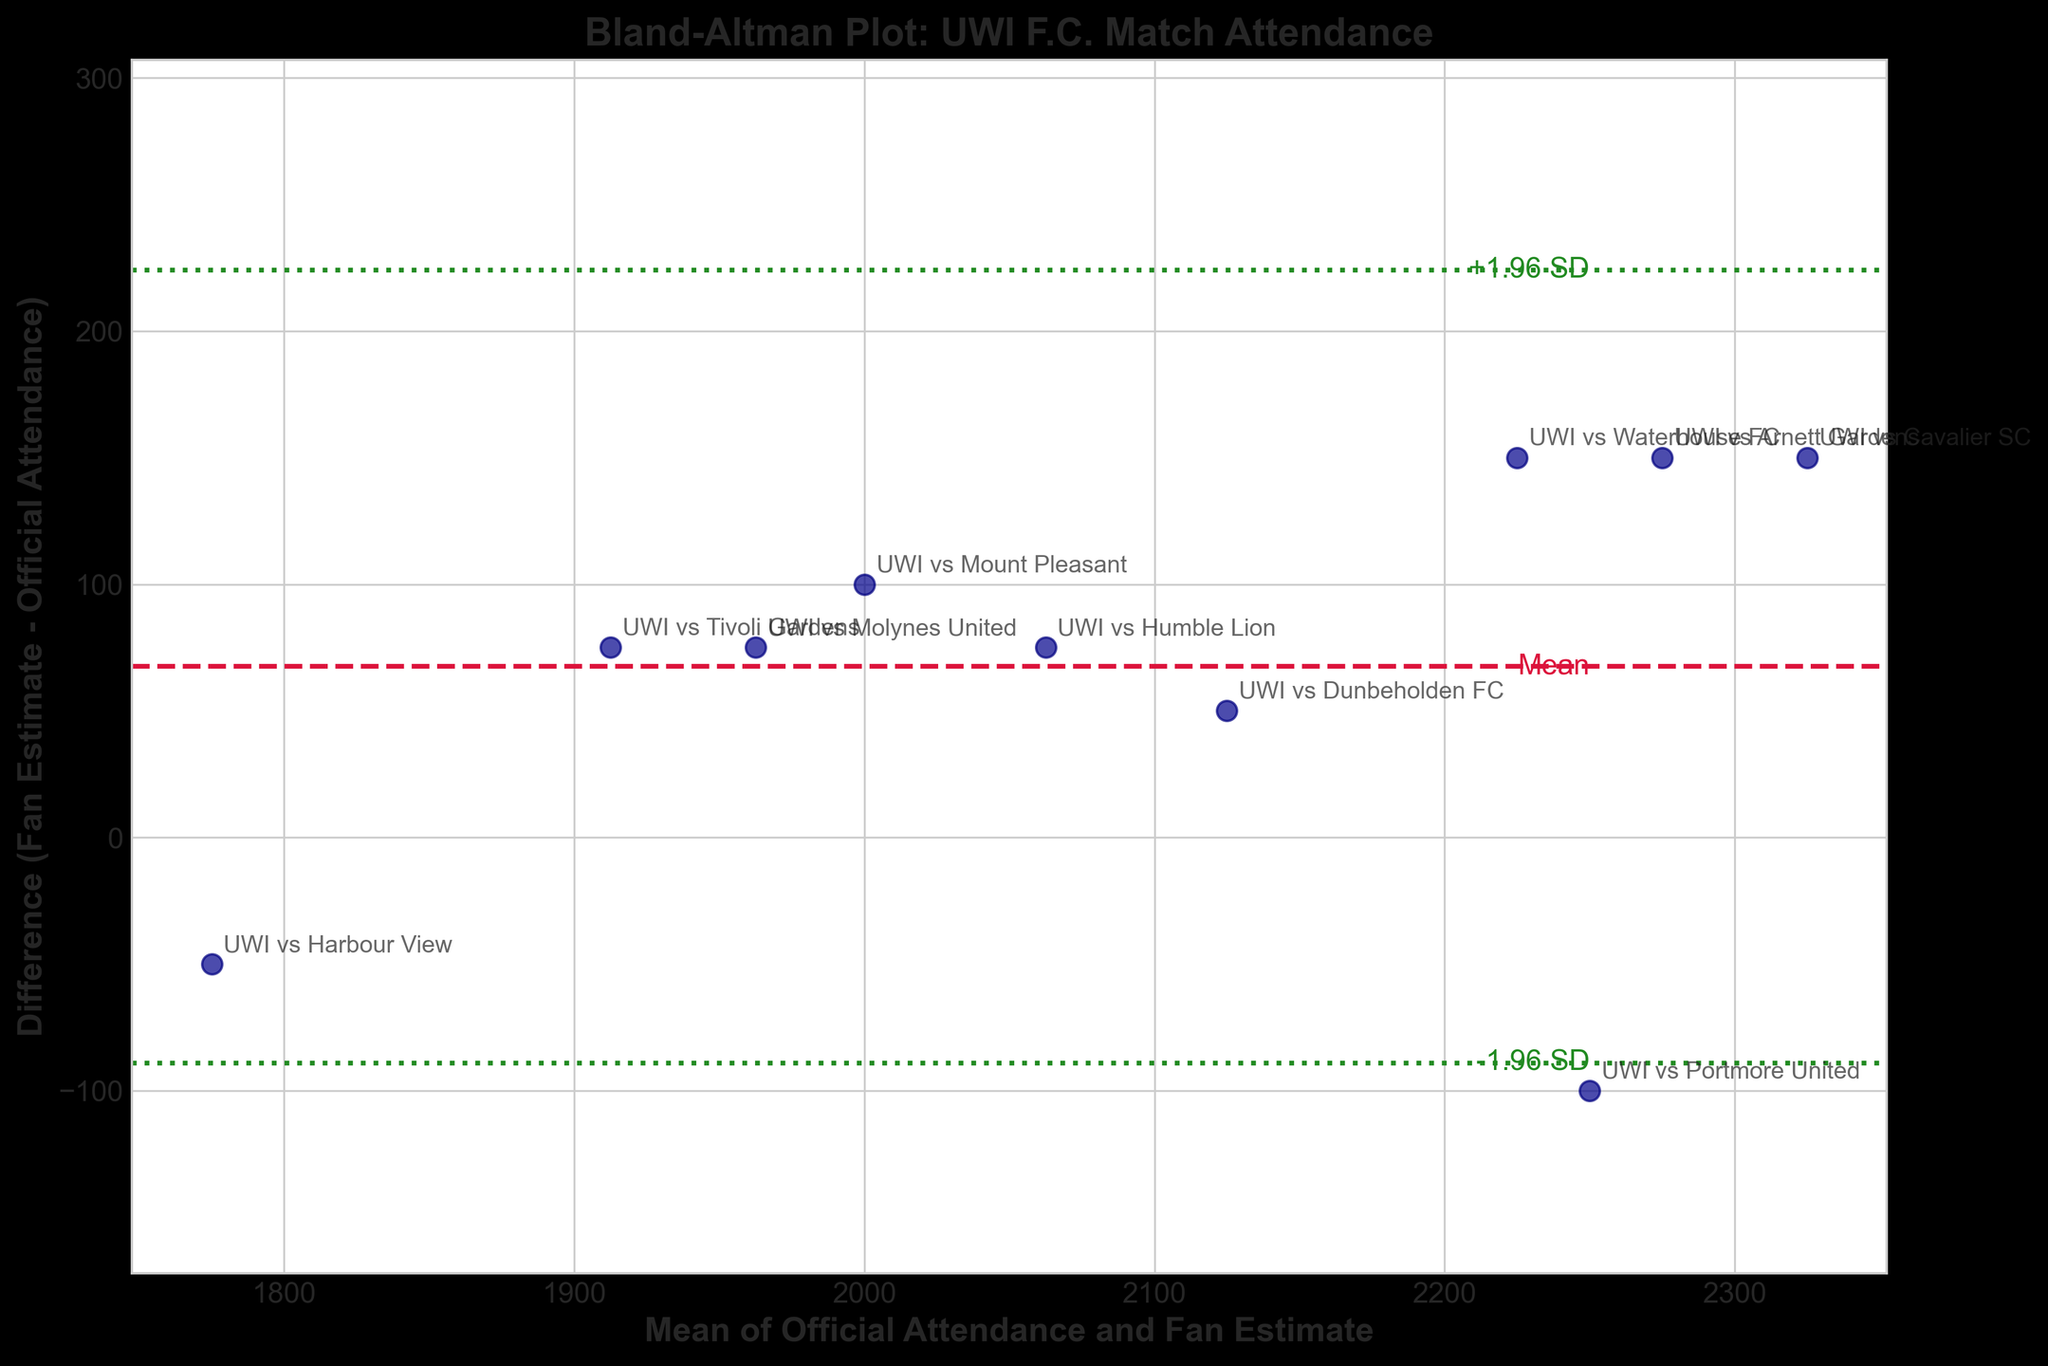What is the title of the plot? The title of the plot is usually located at the top of the figure and explicitly states the main subject of the visualization. In this figure, the title is: Bland-Altman Plot: UWI F.C. Match Attendance.
Answer: Bland-Altman Plot: UWI F.C. Match Attendance What do the x-axis and y-axis represent? The x-axis and y-axis labels give important information about the scales and variables being plotted. In this case, the x-axis represents the "Mean of Official Attendance and Fan Estimate," and the y-axis represents the "Difference (Fan Estimate - Official Attendance)".
Answer: x-axis: Mean of Official Attendance and Fan Estimate, y-axis: Difference (Fan Estimate - Official Attendance) How many matches are compared in this plot? Each point in the scatter represents a match. By counting the data points, we can see there are 10 matches compared in the plot.
Answer: 10 Which match has the largest positive difference (Fan Estimate - Official Attendance)? By observing the data points and looking for the one that is farthest above the central mean line, we see that the match "UWI vs Cavalier SC" has the largest positive difference.
Answer: UWI vs Cavalier SC What is the mean difference between fan estimates and official attendance? The mean difference is indicated by the red dashed line in the plot. The y-position of this line gives the mean difference, noted as around 75.
Answer: 75 What is the standard deviation of the differences between fan estimates and official attendance? To find the standard deviation, observe the distance between the mean line (red dashed line) and the green dotted lines (±1.96 SD). The difference from the mean to these lines is approximately 95; hence, the standard deviation is around 95 / 1.96 which is approximately 48.
Answer: 48 Which matches have fan estimates lower than official attendance? Points below the red dashed mean line indicate where the fan estimates are lower. By checking the data points, we discover that "UWI vs Portmore United" and "UWI vs Harbour View" have fan estimates lower than official attendance.
Answer: UWI vs Portmore United, UWI vs Harbour View What is the range of the differences (Fan Estimate - Official Attendance) observed in the plot? The range of differences can be calculated by finding the minimum and maximum y-values of the points. The minimum difference looks around -50, and the maximum is about 150. So, the range is 150 - (-50) = 200.
Answer: 200 Which match has the smallest mean of official attendance and fan estimate? By observing the x-axis and finding the smallest x-value, we see that the match "UWI vs Harbour View" has the smallest mean.
Answer: UWI vs Harbour View Are there any matches where the fan estimate exactly matches the official attendance? Points on the y-axis value 0 would indicate a perfect match. In this plot, none of the points lie exactly on 0. Hence, there's no match where the fan estimate exactly matches the official attendance.
Answer: No 